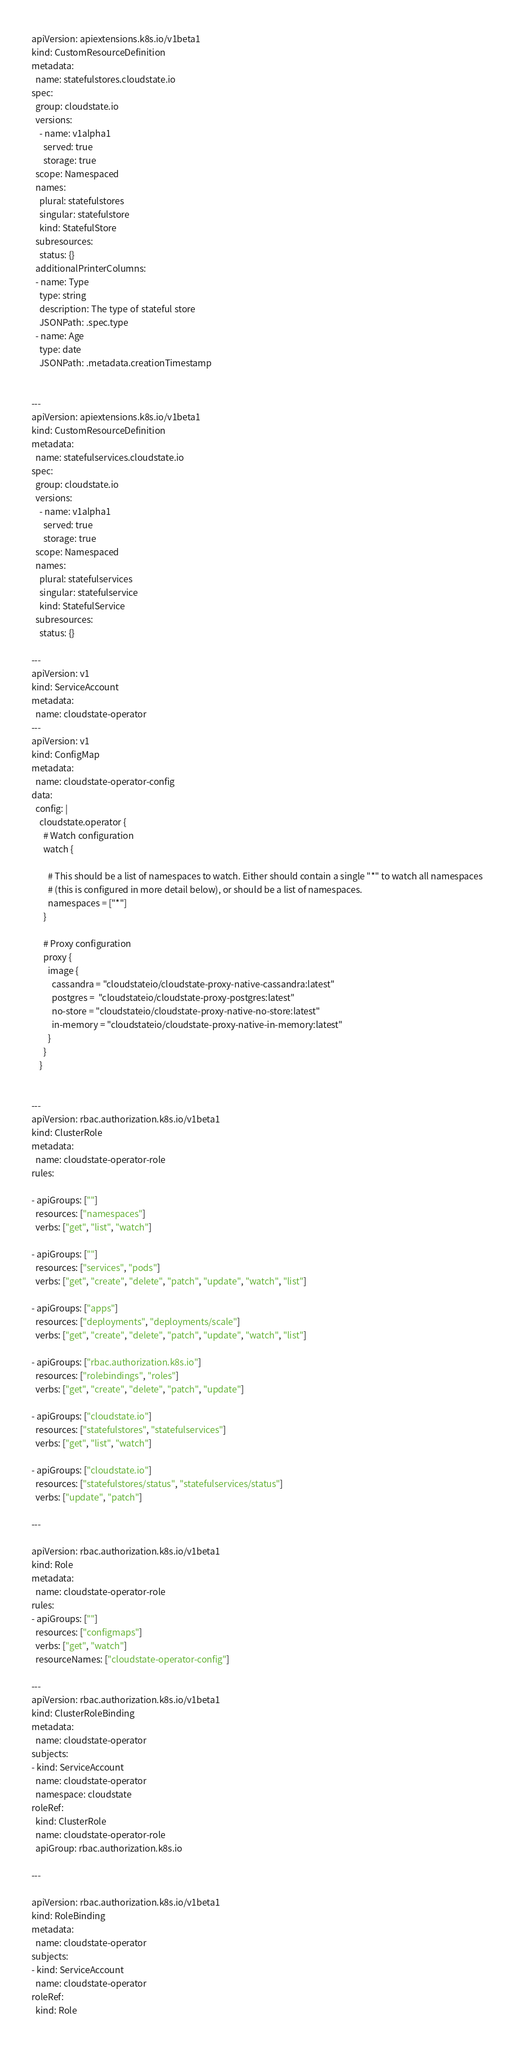Convert code to text. <code><loc_0><loc_0><loc_500><loc_500><_YAML_>apiVersion: apiextensions.k8s.io/v1beta1
kind: CustomResourceDefinition
metadata:
  name: statefulstores.cloudstate.io
spec:
  group: cloudstate.io
  versions:
    - name: v1alpha1
      served: true
      storage: true
  scope: Namespaced
  names:
    plural: statefulstores
    singular: statefulstore
    kind: StatefulStore
  subresources:
    status: {}
  additionalPrinterColumns:
  - name: Type
    type: string
    description: The type of stateful store
    JSONPath: .spec.type
  - name: Age
    type: date
    JSONPath: .metadata.creationTimestamp


---
apiVersion: apiextensions.k8s.io/v1beta1
kind: CustomResourceDefinition
metadata:
  name: statefulservices.cloudstate.io
spec:
  group: cloudstate.io
  versions:
    - name: v1alpha1
      served: true
      storage: true
  scope: Namespaced
  names:
    plural: statefulservices
    singular: statefulservice
    kind: StatefulService
  subresources:
    status: {}

---
apiVersion: v1
kind: ServiceAccount
metadata:
  name: cloudstate-operator
---
apiVersion: v1
kind: ConfigMap
metadata:
  name: cloudstate-operator-config
data:
  config: |
    cloudstate.operator {
      # Watch configuration
      watch {

        # This should be a list of namespaces to watch. Either should contain a single "*" to watch all namespaces
        # (this is configured in more detail below), or should be a list of namespaces.
        namespaces = ["*"]
      }

      # Proxy configuration
      proxy {
        image {
          cassandra = "cloudstateio/cloudstate-proxy-native-cassandra:latest"
          postgres =  "cloudstateio/cloudstate-proxy-postgres:latest"
          no-store = "cloudstateio/cloudstate-proxy-native-no-store:latest"
          in-memory = "cloudstateio/cloudstate-proxy-native-in-memory:latest"
        }
      }
    }


---
apiVersion: rbac.authorization.k8s.io/v1beta1
kind: ClusterRole
metadata:
  name: cloudstate-operator-role
rules:

- apiGroups: [""]
  resources: ["namespaces"]
  verbs: ["get", "list", "watch"]

- apiGroups: [""]
  resources: ["services", "pods"]
  verbs: ["get", "create", "delete", "patch", "update", "watch", "list"]

- apiGroups: ["apps"]
  resources: ["deployments", "deployments/scale"]
  verbs: ["get", "create", "delete", "patch", "update", "watch", "list"]

- apiGroups: ["rbac.authorization.k8s.io"]
  resources: ["rolebindings", "roles"]
  verbs: ["get", "create", "delete", "patch", "update"]

- apiGroups: ["cloudstate.io"]
  resources: ["statefulstores", "statefulservices"]
  verbs: ["get", "list", "watch"]

- apiGroups: ["cloudstate.io"]
  resources: ["statefulstores/status", "statefulservices/status"]
  verbs: ["update", "patch"]

---

apiVersion: rbac.authorization.k8s.io/v1beta1
kind: Role
metadata:
  name: cloudstate-operator-role
rules:
- apiGroups: [""]
  resources: ["configmaps"]
  verbs: ["get", "watch"]
  resourceNames: ["cloudstate-operator-config"]

---
apiVersion: rbac.authorization.k8s.io/v1beta1
kind: ClusterRoleBinding
metadata:
  name: cloudstate-operator
subjects:
- kind: ServiceAccount
  name: cloudstate-operator
  namespace: cloudstate
roleRef:
  kind: ClusterRole
  name: cloudstate-operator-role
  apiGroup: rbac.authorization.k8s.io

---

apiVersion: rbac.authorization.k8s.io/v1beta1
kind: RoleBinding
metadata:
  name: cloudstate-operator
subjects:
- kind: ServiceAccount
  name: cloudstate-operator
roleRef:
  kind: Role</code> 